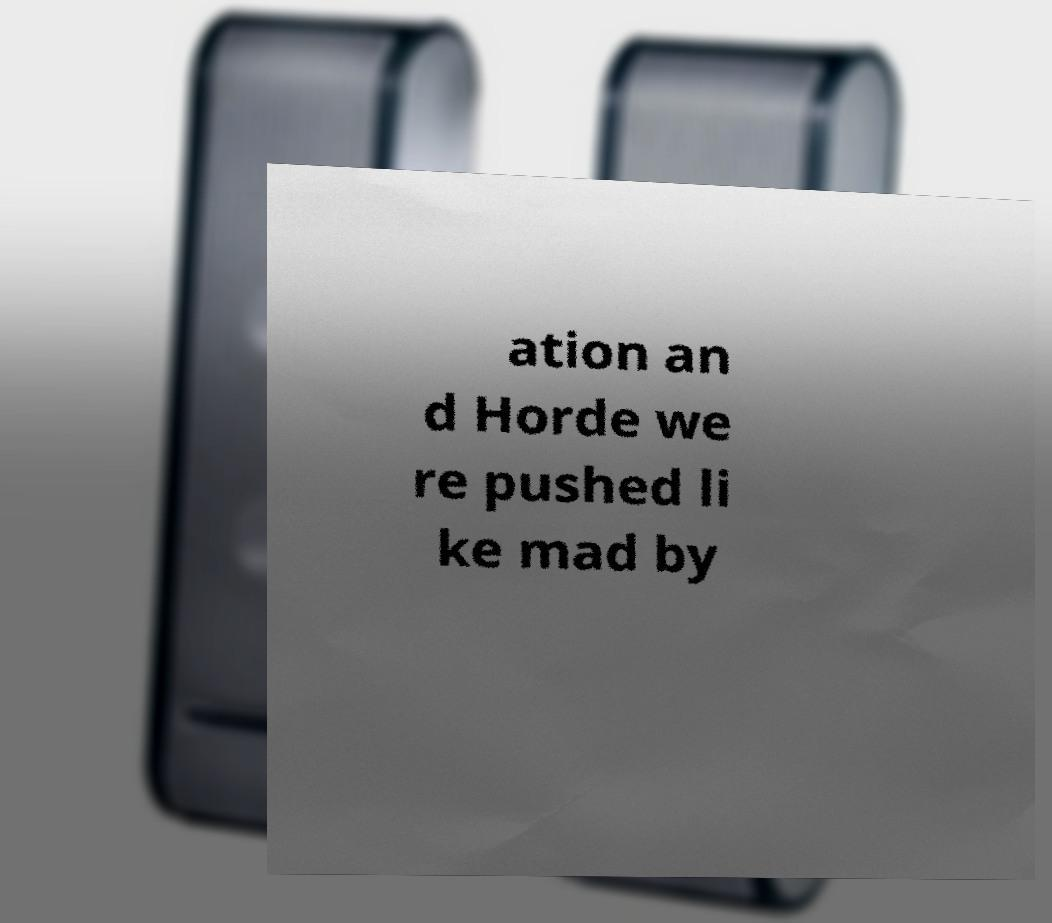Please read and relay the text visible in this image. What does it say? ation an d Horde we re pushed li ke mad by 